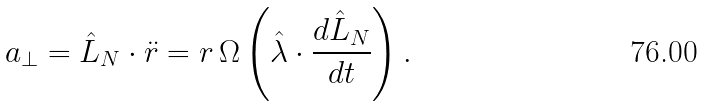<formula> <loc_0><loc_0><loc_500><loc_500>a _ { \perp } = \hat { L } _ { N } \cdot \ddot { r } = r \, \Omega \left ( \hat { \lambda } \cdot \frac { d \hat { L } _ { N } } { d t } \right ) .</formula> 